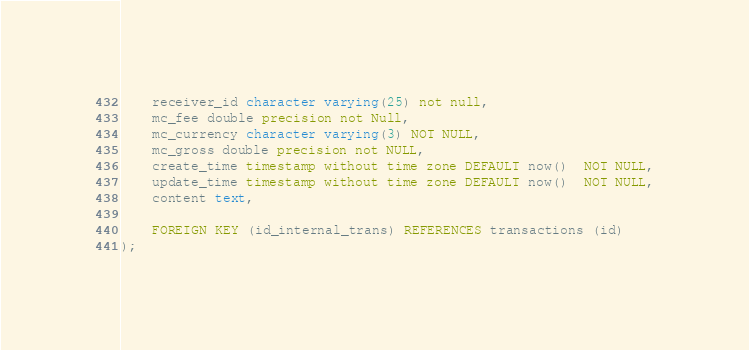Convert code to text. <code><loc_0><loc_0><loc_500><loc_500><_SQL_>    receiver_id character varying(25) not null,
    mc_fee double precision not Null,
    mc_currency character varying(3) NOT NULL,
    mc_gross double precision not NULL,
    create_time timestamp without time zone DEFAULT now()  NOT NULL,
    update_time timestamp without time zone DEFAULT now()  NOT NULL,
    content text,

    FOREIGN KEY (id_internal_trans) REFERENCES transactions (id)
);</code> 